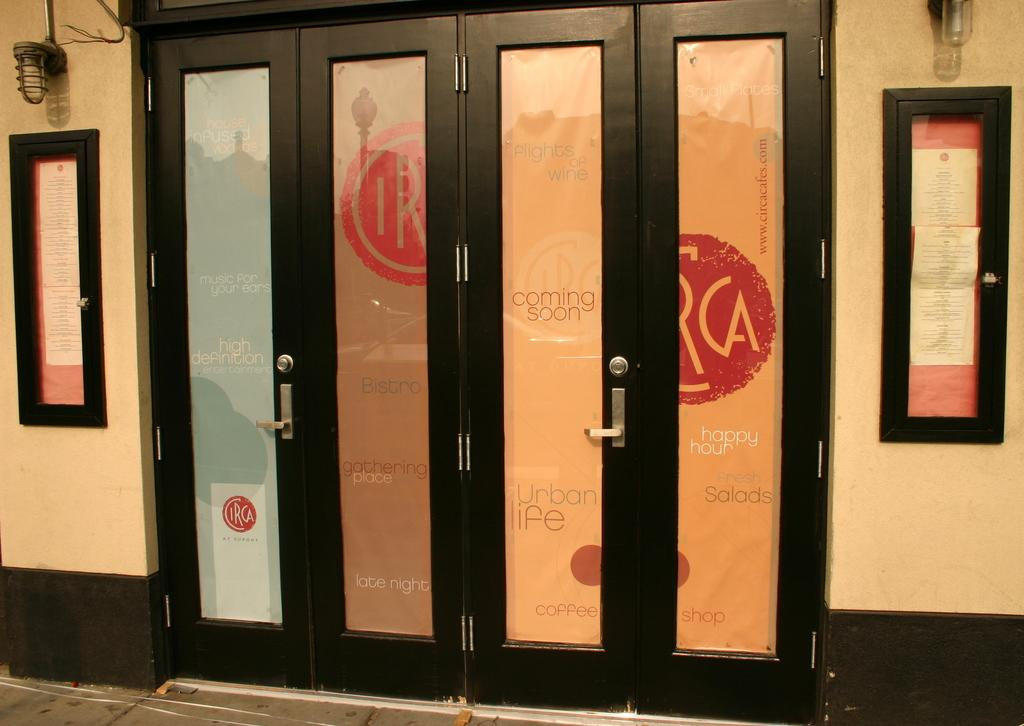What type of structure is visible in the image? There are doors in the image. What can be seen on the right side of the box in the image? There are posters on the right side of the box. What is attached to the left side of the box in the image? There are papers attached to the left side of the box. What is present at the top of the box in the image? There are lights at the top of the box. What color is the ink on the fly that is sitting on the jelly in the image? There is no ink, fly, or jelly present in the image. 